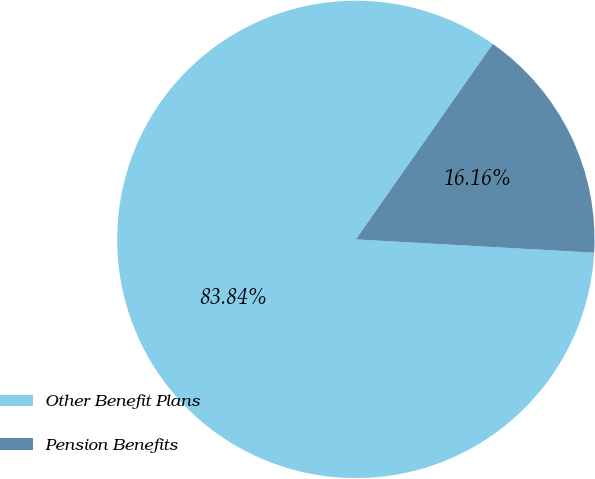<chart> <loc_0><loc_0><loc_500><loc_500><pie_chart><fcel>Other Benefit Plans<fcel>Pension Benefits<nl><fcel>83.84%<fcel>16.16%<nl></chart> 